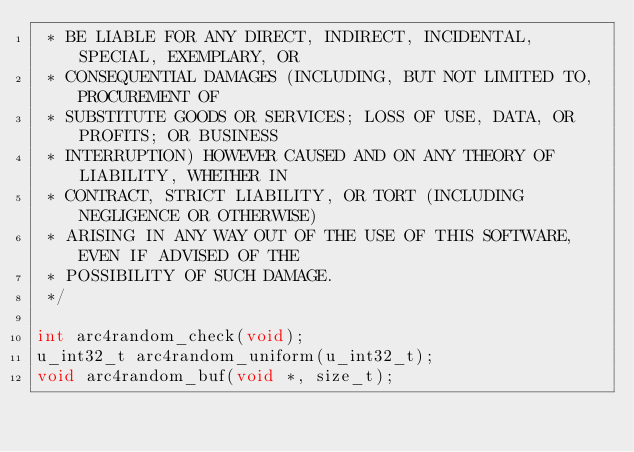<code> <loc_0><loc_0><loc_500><loc_500><_C_> * BE LIABLE FOR ANY DIRECT, INDIRECT, INCIDENTAL, SPECIAL, EXEMPLARY, OR
 * CONSEQUENTIAL DAMAGES (INCLUDING, BUT NOT LIMITED TO, PROCUREMENT OF
 * SUBSTITUTE GOODS OR SERVICES; LOSS OF USE, DATA, OR PROFITS; OR BUSINESS
 * INTERRUPTION) HOWEVER CAUSED AND ON ANY THEORY OF LIABILITY, WHETHER IN
 * CONTRACT, STRICT LIABILITY, OR TORT (INCLUDING NEGLIGENCE OR OTHERWISE)
 * ARISING IN ANY WAY OUT OF THE USE OF THIS SOFTWARE, EVEN IF ADVISED OF THE
 * POSSIBILITY OF SUCH DAMAGE.
 */

int arc4random_check(void);
u_int32_t arc4random_uniform(u_int32_t);
void arc4random_buf(void *, size_t);
</code> 